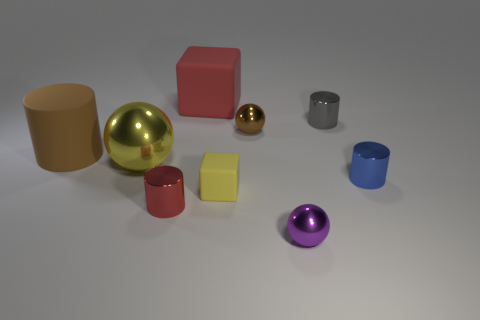Subtract all red cylinders. How many cylinders are left? 3 Subtract all small gray cylinders. How many cylinders are left? 3 Subtract all purple cylinders. Subtract all brown cubes. How many cylinders are left? 4 Add 1 yellow objects. How many objects exist? 10 Subtract all cubes. How many objects are left? 7 Add 9 large shiny balls. How many large shiny balls are left? 10 Add 9 tiny brown rubber balls. How many tiny brown rubber balls exist? 9 Subtract 0 yellow cylinders. How many objects are left? 9 Subtract all yellow rubber objects. Subtract all big red rubber objects. How many objects are left? 7 